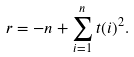<formula> <loc_0><loc_0><loc_500><loc_500>r = - n + \sum _ { i = 1 } ^ { n } t ( i ) ^ { 2 } .</formula> 